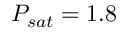<formula> <loc_0><loc_0><loc_500><loc_500>P _ { s a t } = 1 . 8</formula> 